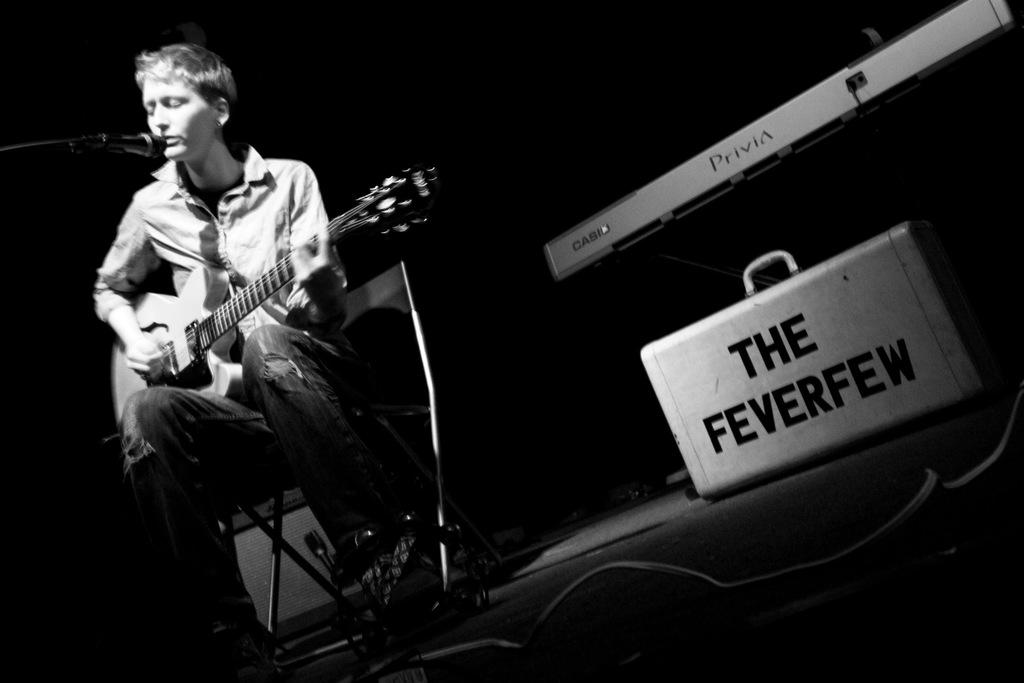What is the man in the image doing? The man is sitting on a chair, playing the guitar, and singing into a microphone. What instrument is the man holding in his hand? The man is holding a guitar in his hand. What other musical instrument can be seen in the image? There is a piano in the image. What object is present in the image that might be used for carrying belongings? There is a suitcase in the image. How would you describe the lighting in the image? The image is dark. What type of fuel is the man using to power his performance in the image? There is no mention of fuel in the image, as the man is playing a guitar and singing into a microphone, which do not require fuel. Can you see a chain attached to the guitar in the image? There is no chain visible in the image; the man is simply holding the guitar in his hand. 